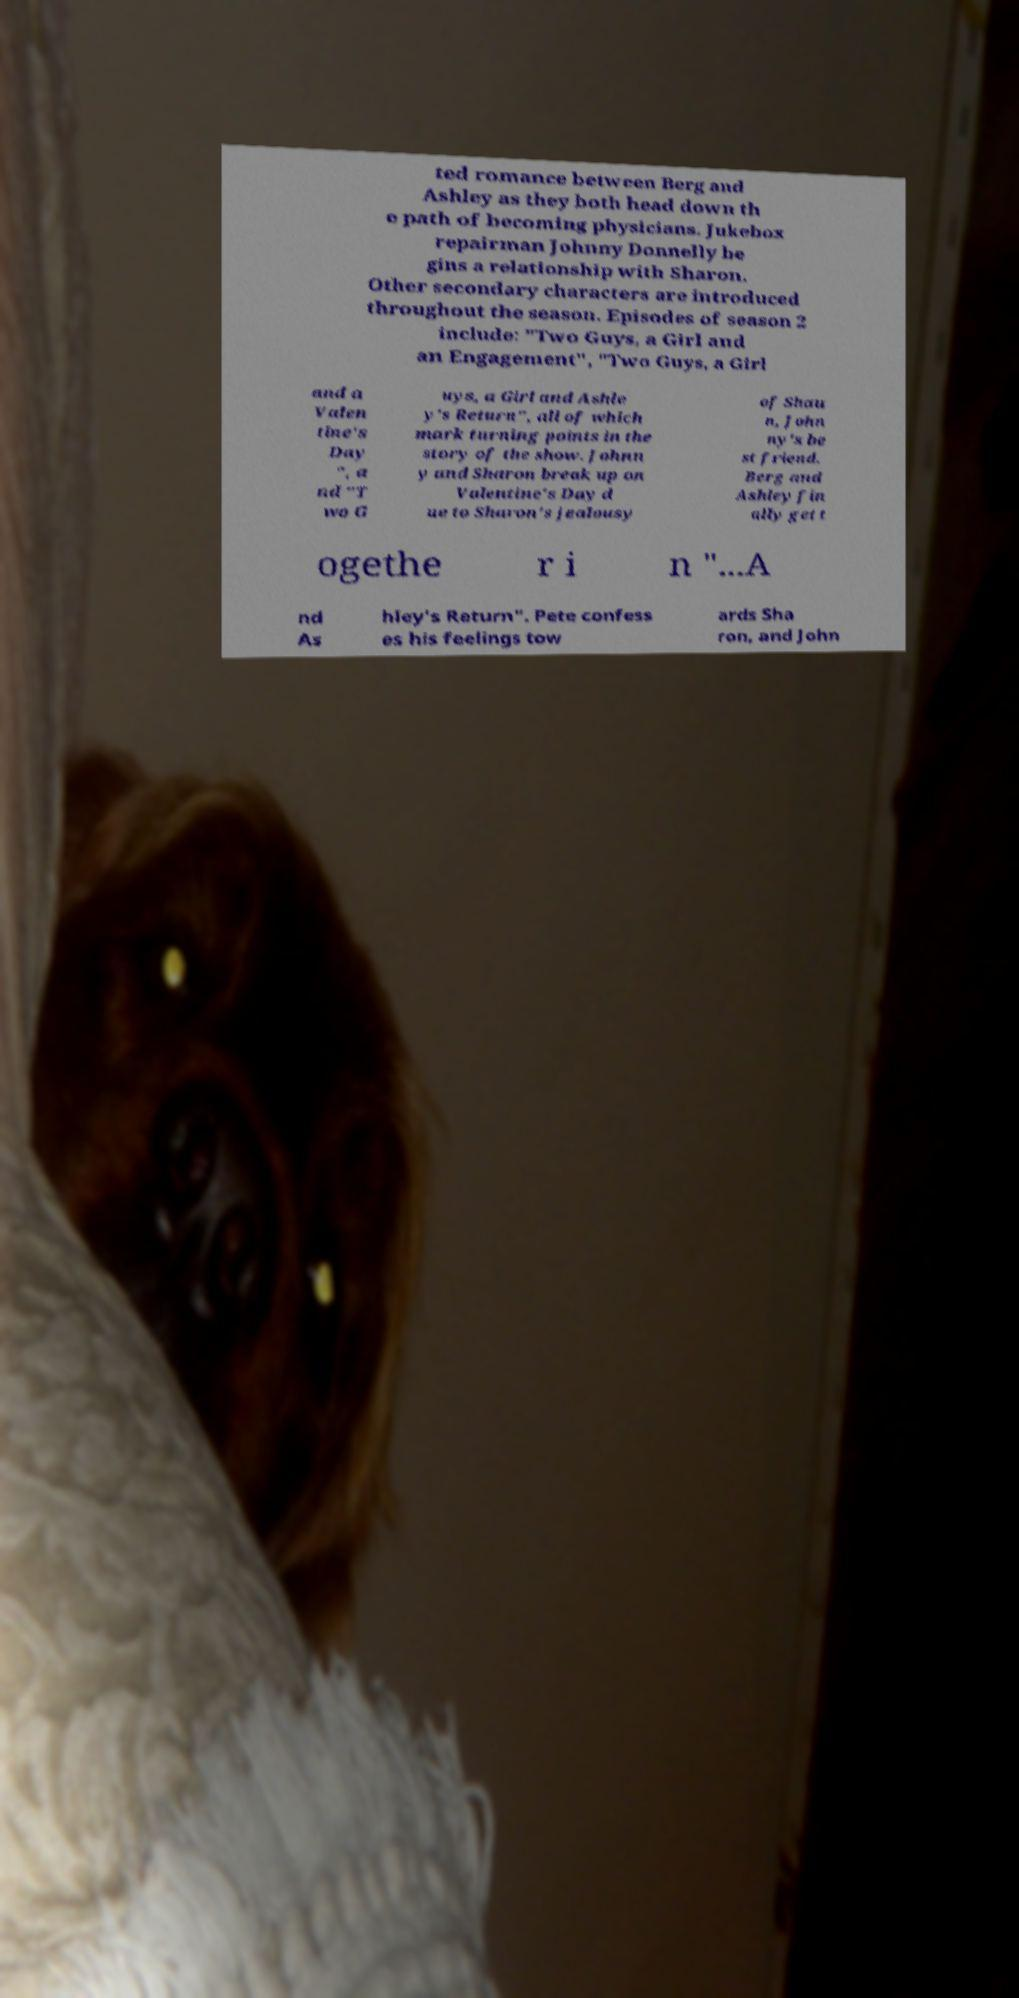I need the written content from this picture converted into text. Can you do that? ted romance between Berg and Ashley as they both head down th e path of becoming physicians. Jukebox repairman Johnny Donnelly be gins a relationship with Sharon. Other secondary characters are introduced throughout the season. Episodes of season 2 include: "Two Guys, a Girl and an Engagement", "Two Guys, a Girl and a Valen tine's Day ", a nd "T wo G uys, a Girl and Ashle y's Return", all of which mark turning points in the story of the show. Johnn y and Sharon break up on Valentine's Day d ue to Sharon's jealousy of Shau n, John ny's be st friend. Berg and Ashley fin ally get t ogethe r i n "...A nd As hley's Return". Pete confess es his feelings tow ards Sha ron, and John 